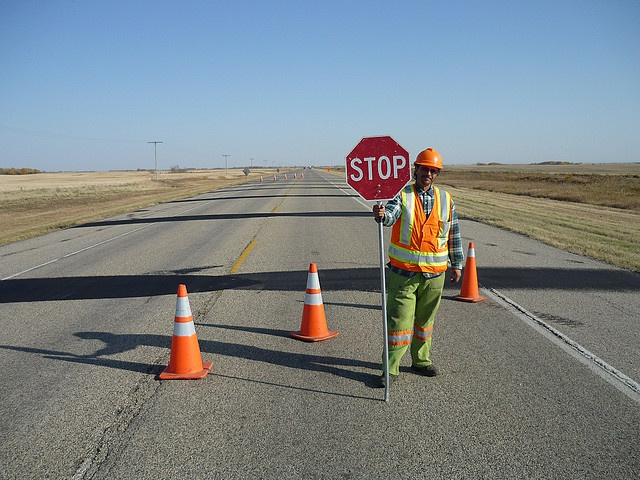Describe the objects in this image and their specific colors. I can see people in gray, black, olive, and darkgray tones and stop sign in gray, maroon, brown, darkgray, and lightblue tones in this image. 